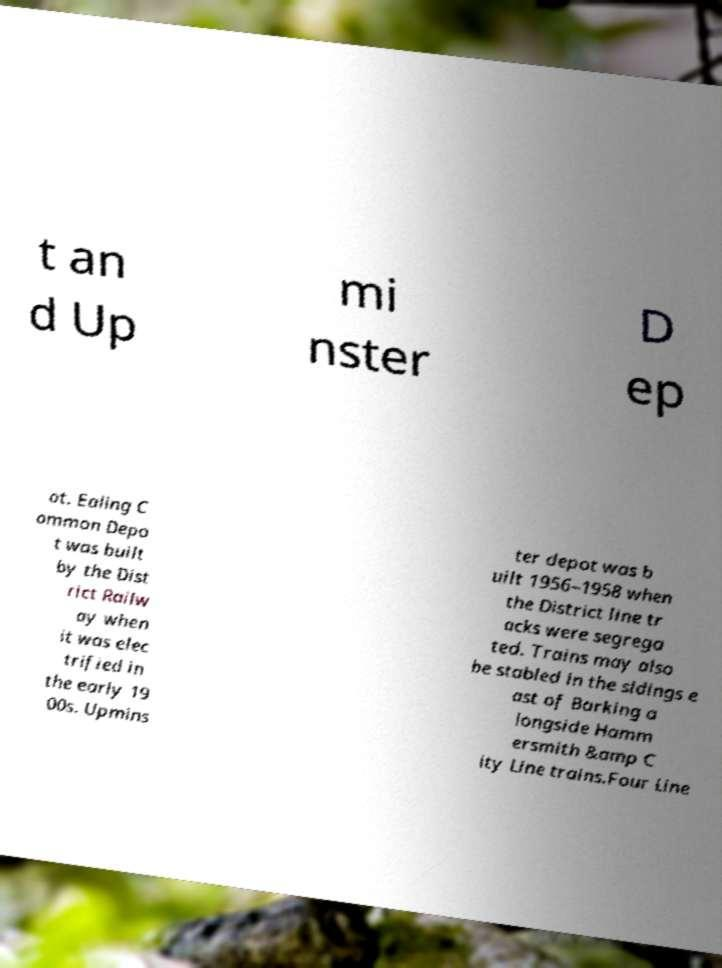Please read and relay the text visible in this image. What does it say? t an d Up mi nster D ep ot. Ealing C ommon Depo t was built by the Dist rict Railw ay when it was elec trified in the early 19 00s. Upmins ter depot was b uilt 1956–1958 when the District line tr acks were segrega ted. Trains may also be stabled in the sidings e ast of Barking a longside Hamm ersmith &amp C ity Line trains.Four Line 